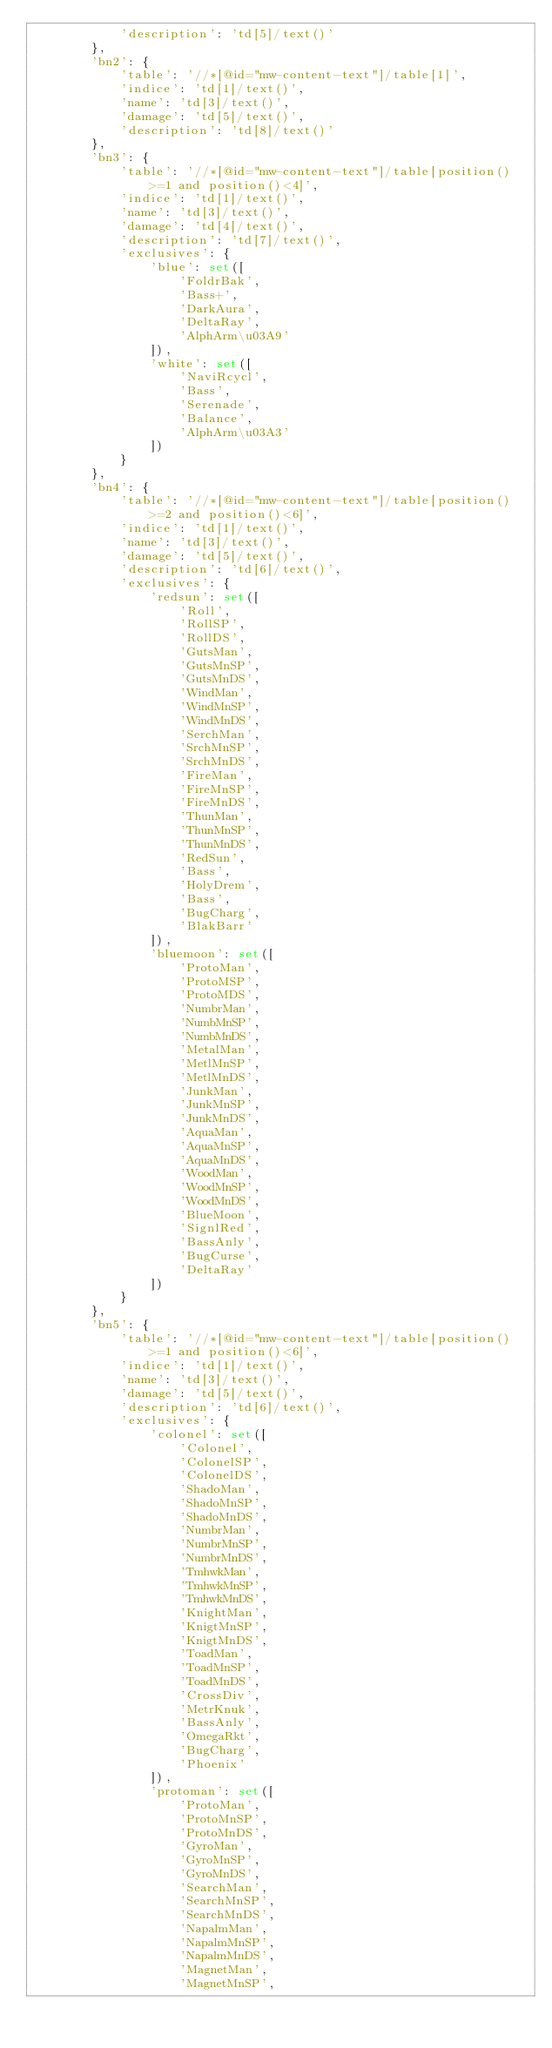<code> <loc_0><loc_0><loc_500><loc_500><_Python_>            'description': 'td[5]/text()'
        },
        'bn2': {
            'table': '//*[@id="mw-content-text"]/table[1]',
            'indice': 'td[1]/text()',
            'name': 'td[3]/text()',
            'damage': 'td[5]/text()',
            'description': 'td[8]/text()'
        },
        'bn3': {
            'table': '//*[@id="mw-content-text"]/table[position()>=1 and position()<4]',
            'indice': 'td[1]/text()',
            'name': 'td[3]/text()',
            'damage': 'td[4]/text()',
            'description': 'td[7]/text()',
            'exclusives': {
                'blue': set([
                    'FoldrBak',
                    'Bass+',
                    'DarkAura',
                    'DeltaRay',
                    'AlphArm\u03A9'
                ]),
                'white': set([
                    'NaviRcycl',
                    'Bass',
                    'Serenade',
                    'Balance',
                    'AlphArm\u03A3'
                ])
            }
        },
        'bn4': {
            'table': '//*[@id="mw-content-text"]/table[position()>=2 and position()<6]',
            'indice': 'td[1]/text()',
            'name': 'td[3]/text()',
            'damage': 'td[5]/text()',
            'description': 'td[6]/text()',
            'exclusives': {
                'redsun': set([
                    'Roll',
                    'RollSP',
                    'RollDS',
                    'GutsMan',
                    'GutsMnSP',
                    'GutsMnDS',
                    'WindMan',
                    'WindMnSP',
                    'WindMnDS',
                    'SerchMan',
                    'SrchMnSP',
                    'SrchMnDS',
                    'FireMan',
                    'FireMnSP',
                    'FireMnDS',
                    'ThunMan',
                    'ThunMnSP',
                    'ThunMnDS',
                    'RedSun',
                    'Bass',
                    'HolyDrem',
                    'Bass',
                    'BugCharg',
                    'BlakBarr'
                ]),
                'bluemoon': set([
                    'ProtoMan',
                    'ProtoMSP',
                    'ProtoMDS',
                    'NumbrMan',
                    'NumbMnSP',
                    'NumbMnDS',
                    'MetalMan',
                    'MetlMnSP',
                    'MetlMnDS',
                    'JunkMan',
                    'JunkMnSP',
                    'JunkMnDS',
                    'AquaMan',
                    'AquaMnSP',
                    'AquaMnDS',
                    'WoodMan',
                    'WoodMnSP',
                    'WoodMnDS',
                    'BlueMoon',
                    'SignlRed',
                    'BassAnly',
                    'BugCurse',
                    'DeltaRay'
                ])
            }
        },
        'bn5': {
            'table': '//*[@id="mw-content-text"]/table[position()>=1 and position()<6]',
            'indice': 'td[1]/text()',
            'name': 'td[3]/text()',
            'damage': 'td[5]/text()',
            'description': 'td[6]/text()',
            'exclusives': {
                'colonel': set([
                    'Colonel',
                    'ColonelSP',
                    'ColonelDS',
                    'ShadoMan',
                    'ShadoMnSP',
                    'ShadoMnDS',
                    'NumbrMan',
                    'NumbrMnSP',
                    'NumbrMnDS',
                    'TmhwkMan',
                    'TmhwkMnSP',
                    'TmhwkMnDS',
                    'KnightMan',
                    'KnigtMnSP',
                    'KnigtMnDS',
                    'ToadMan',
                    'ToadMnSP',
                    'ToadMnDS',
                    'CrossDiv',
                    'MetrKnuk',
                    'BassAnly',
                    'OmegaRkt',
                    'BugCharg',
                    'Phoenix'
                ]),
                'protoman': set([
                    'ProtoMan',
                    'ProtoMnSP',
                    'ProtoMnDS',
                    'GyroMan',
                    'GyroMnSP',
                    'GyroMnDS',
                    'SearchMan',
                    'SearchMnSP',
                    'SearchMnDS',
                    'NapalmMan',
                    'NapalmMnSP',
                    'NapalmMnDS',
                    'MagnetMan',
                    'MagnetMnSP',</code> 